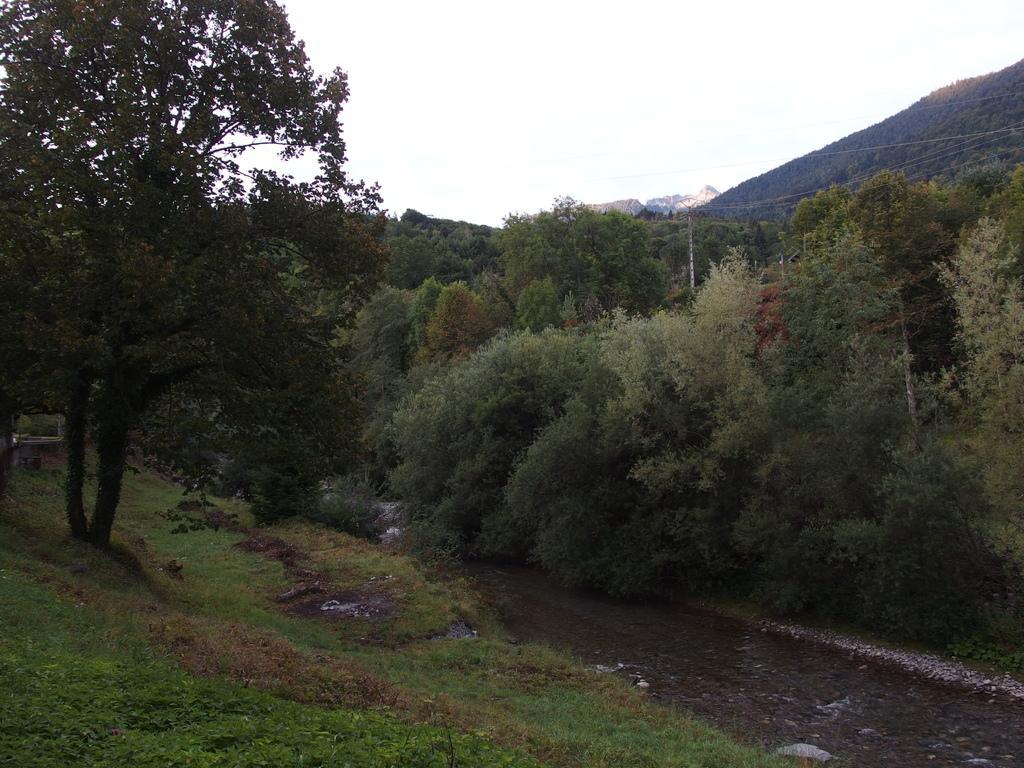Please provide a concise description of this image. In this image I can see mountains and trees and a lake flowing through trees. At the top of the image I can see the sky.   